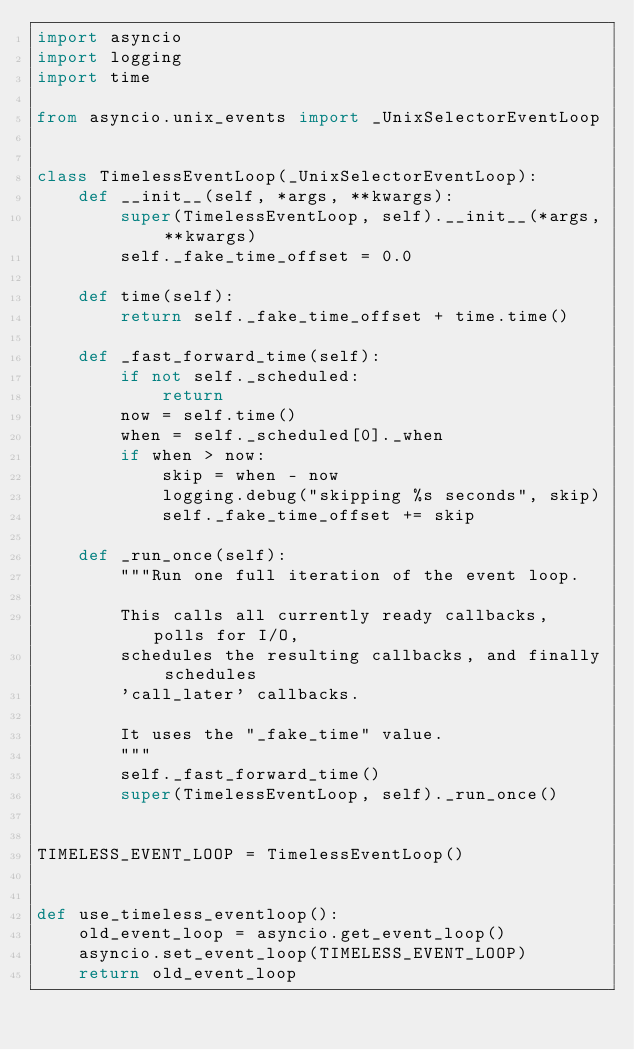Convert code to text. <code><loc_0><loc_0><loc_500><loc_500><_Python_>import asyncio
import logging
import time

from asyncio.unix_events import _UnixSelectorEventLoop


class TimelessEventLoop(_UnixSelectorEventLoop):
    def __init__(self, *args, **kwargs):
        super(TimelessEventLoop, self).__init__(*args, **kwargs)
        self._fake_time_offset = 0.0

    def time(self):
        return self._fake_time_offset + time.time()

    def _fast_forward_time(self):
        if not self._scheduled:
            return
        now = self.time()
        when = self._scheduled[0]._when
        if when > now:
            skip = when - now
            logging.debug("skipping %s seconds", skip)
            self._fake_time_offset += skip

    def _run_once(self):
        """Run one full iteration of the event loop.

        This calls all currently ready callbacks, polls for I/O,
        schedules the resulting callbacks, and finally schedules
        'call_later' callbacks.

        It uses the "_fake_time" value.
        """
        self._fast_forward_time()
        super(TimelessEventLoop, self)._run_once()


TIMELESS_EVENT_LOOP = TimelessEventLoop()


def use_timeless_eventloop():
    old_event_loop = asyncio.get_event_loop()
    asyncio.set_event_loop(TIMELESS_EVENT_LOOP)
    return old_event_loop
</code> 